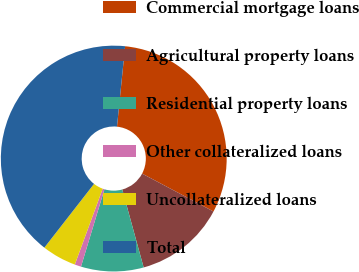Convert chart. <chart><loc_0><loc_0><loc_500><loc_500><pie_chart><fcel>Commercial mortgage loans<fcel>Agricultural property loans<fcel>Residential property loans<fcel>Other collateralized loans<fcel>Uncollateralized loans<fcel>Total<nl><fcel>31.16%<fcel>12.97%<fcel>8.95%<fcel>0.92%<fcel>4.93%<fcel>41.07%<nl></chart> 